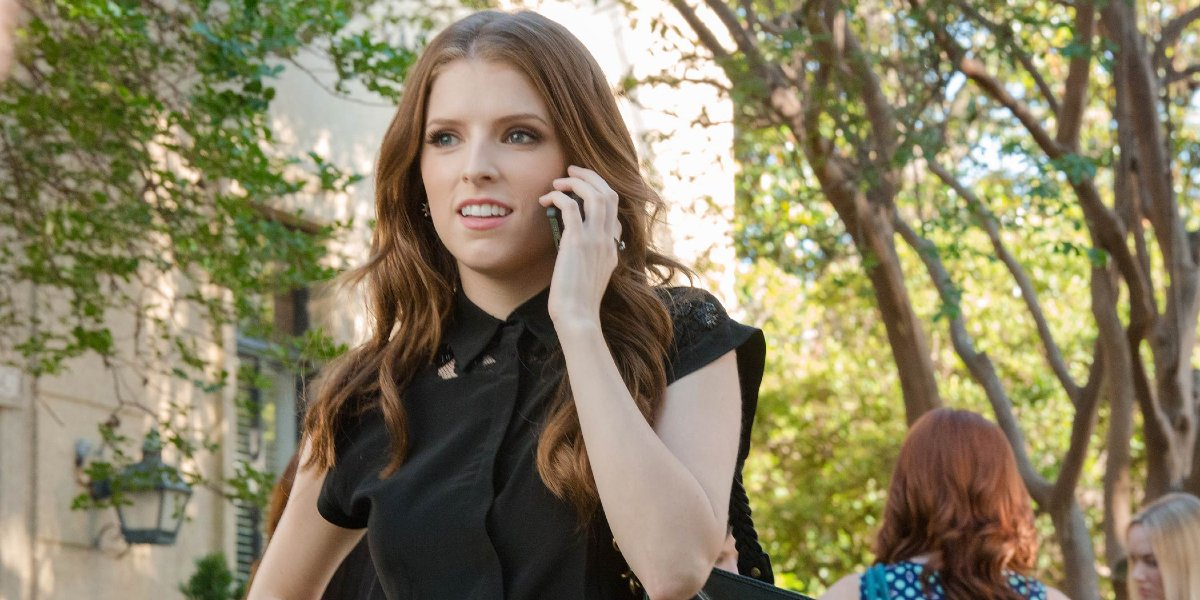Can you describe the woman's attire? Sure, the woman in the image is wearing a smart-casual black top with detail at the collar. Her attire suggests a blend of comfort and professionalism. 